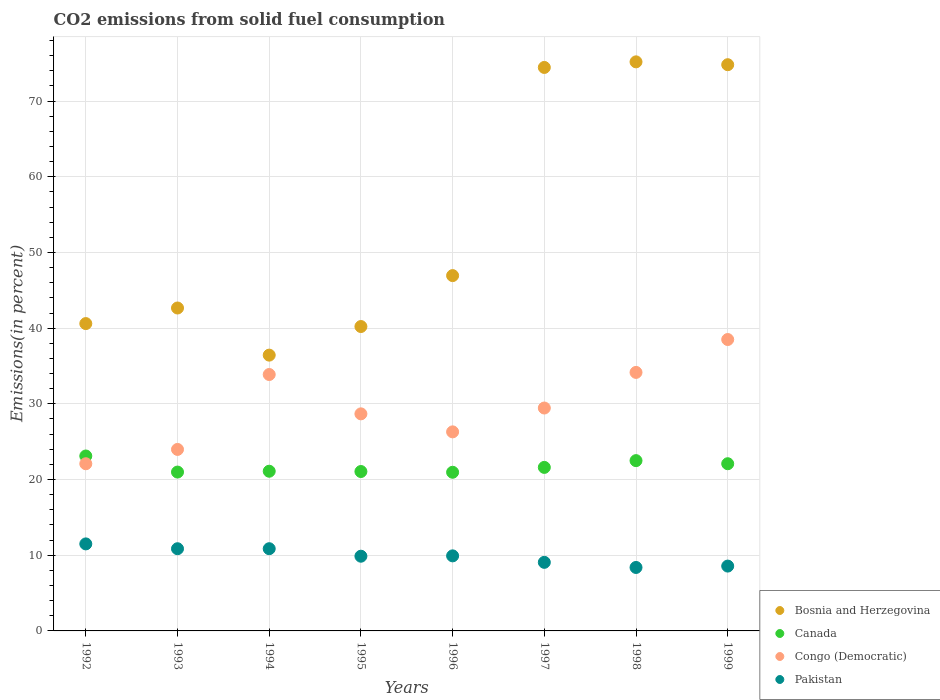How many different coloured dotlines are there?
Your response must be concise. 4. Is the number of dotlines equal to the number of legend labels?
Offer a terse response. Yes. What is the total CO2 emitted in Canada in 1999?
Your answer should be very brief. 22.09. Across all years, what is the maximum total CO2 emitted in Bosnia and Herzegovina?
Keep it short and to the point. 75.18. Across all years, what is the minimum total CO2 emitted in Pakistan?
Offer a terse response. 8.38. In which year was the total CO2 emitted in Canada minimum?
Make the answer very short. 1996. What is the total total CO2 emitted in Pakistan in the graph?
Provide a succinct answer. 79.01. What is the difference between the total CO2 emitted in Pakistan in 1995 and that in 1996?
Provide a succinct answer. -0.05. What is the difference between the total CO2 emitted in Bosnia and Herzegovina in 1992 and the total CO2 emitted in Pakistan in 1995?
Offer a terse response. 30.73. What is the average total CO2 emitted in Canada per year?
Ensure brevity in your answer.  21.68. In the year 1993, what is the difference between the total CO2 emitted in Congo (Democratic) and total CO2 emitted in Pakistan?
Keep it short and to the point. 13.12. What is the ratio of the total CO2 emitted in Bosnia and Herzegovina in 1992 to that in 1997?
Your answer should be compact. 0.55. What is the difference between the highest and the second highest total CO2 emitted in Pakistan?
Provide a succinct answer. 0.63. What is the difference between the highest and the lowest total CO2 emitted in Canada?
Your answer should be very brief. 2.15. In how many years, is the total CO2 emitted in Canada greater than the average total CO2 emitted in Canada taken over all years?
Provide a short and direct response. 3. Is the sum of the total CO2 emitted in Congo (Democratic) in 1994 and 1995 greater than the maximum total CO2 emitted in Pakistan across all years?
Keep it short and to the point. Yes. Does the total CO2 emitted in Bosnia and Herzegovina monotonically increase over the years?
Offer a very short reply. No. How many dotlines are there?
Provide a short and direct response. 4. How many years are there in the graph?
Keep it short and to the point. 8. What is the difference between two consecutive major ticks on the Y-axis?
Your response must be concise. 10. Are the values on the major ticks of Y-axis written in scientific E-notation?
Your response must be concise. No. Where does the legend appear in the graph?
Give a very brief answer. Bottom right. How are the legend labels stacked?
Your answer should be very brief. Vertical. What is the title of the graph?
Provide a succinct answer. CO2 emissions from solid fuel consumption. Does "Finland" appear as one of the legend labels in the graph?
Make the answer very short. No. What is the label or title of the X-axis?
Ensure brevity in your answer.  Years. What is the label or title of the Y-axis?
Offer a very short reply. Emissions(in percent). What is the Emissions(in percent) in Bosnia and Herzegovina in 1992?
Ensure brevity in your answer.  40.6. What is the Emissions(in percent) in Canada in 1992?
Your answer should be compact. 23.11. What is the Emissions(in percent) in Congo (Democratic) in 1992?
Your answer should be compact. 22.09. What is the Emissions(in percent) in Pakistan in 1992?
Your answer should be very brief. 11.5. What is the Emissions(in percent) of Bosnia and Herzegovina in 1993?
Keep it short and to the point. 42.66. What is the Emissions(in percent) of Canada in 1993?
Your response must be concise. 20.99. What is the Emissions(in percent) of Congo (Democratic) in 1993?
Offer a very short reply. 23.98. What is the Emissions(in percent) in Pakistan in 1993?
Offer a very short reply. 10.86. What is the Emissions(in percent) of Bosnia and Herzegovina in 1994?
Make the answer very short. 36.44. What is the Emissions(in percent) in Canada in 1994?
Ensure brevity in your answer.  21.1. What is the Emissions(in percent) in Congo (Democratic) in 1994?
Give a very brief answer. 33.88. What is the Emissions(in percent) of Pakistan in 1994?
Keep it short and to the point. 10.86. What is the Emissions(in percent) of Bosnia and Herzegovina in 1995?
Make the answer very short. 40.21. What is the Emissions(in percent) in Canada in 1995?
Offer a terse response. 21.06. What is the Emissions(in percent) in Congo (Democratic) in 1995?
Make the answer very short. 28.68. What is the Emissions(in percent) in Pakistan in 1995?
Provide a succinct answer. 9.87. What is the Emissions(in percent) of Bosnia and Herzegovina in 1996?
Your answer should be very brief. 46.94. What is the Emissions(in percent) in Canada in 1996?
Give a very brief answer. 20.96. What is the Emissions(in percent) of Congo (Democratic) in 1996?
Make the answer very short. 26.3. What is the Emissions(in percent) in Pakistan in 1996?
Your answer should be compact. 9.92. What is the Emissions(in percent) of Bosnia and Herzegovina in 1997?
Ensure brevity in your answer.  74.44. What is the Emissions(in percent) in Canada in 1997?
Your response must be concise. 21.6. What is the Emissions(in percent) in Congo (Democratic) in 1997?
Offer a very short reply. 29.45. What is the Emissions(in percent) in Pakistan in 1997?
Ensure brevity in your answer.  9.06. What is the Emissions(in percent) in Bosnia and Herzegovina in 1998?
Give a very brief answer. 75.18. What is the Emissions(in percent) of Canada in 1998?
Keep it short and to the point. 22.5. What is the Emissions(in percent) of Congo (Democratic) in 1998?
Your answer should be very brief. 34.15. What is the Emissions(in percent) of Pakistan in 1998?
Keep it short and to the point. 8.38. What is the Emissions(in percent) of Bosnia and Herzegovina in 1999?
Your answer should be very brief. 74.81. What is the Emissions(in percent) in Canada in 1999?
Your answer should be compact. 22.09. What is the Emissions(in percent) in Congo (Democratic) in 1999?
Make the answer very short. 38.5. What is the Emissions(in percent) of Pakistan in 1999?
Provide a succinct answer. 8.57. Across all years, what is the maximum Emissions(in percent) in Bosnia and Herzegovina?
Your answer should be very brief. 75.18. Across all years, what is the maximum Emissions(in percent) in Canada?
Offer a very short reply. 23.11. Across all years, what is the maximum Emissions(in percent) in Congo (Democratic)?
Provide a succinct answer. 38.5. Across all years, what is the maximum Emissions(in percent) of Pakistan?
Keep it short and to the point. 11.5. Across all years, what is the minimum Emissions(in percent) in Bosnia and Herzegovina?
Give a very brief answer. 36.44. Across all years, what is the minimum Emissions(in percent) in Canada?
Provide a short and direct response. 20.96. Across all years, what is the minimum Emissions(in percent) of Congo (Democratic)?
Make the answer very short. 22.09. Across all years, what is the minimum Emissions(in percent) in Pakistan?
Your answer should be very brief. 8.38. What is the total Emissions(in percent) in Bosnia and Herzegovina in the graph?
Keep it short and to the point. 431.29. What is the total Emissions(in percent) of Canada in the graph?
Make the answer very short. 173.4. What is the total Emissions(in percent) in Congo (Democratic) in the graph?
Make the answer very short. 237.02. What is the total Emissions(in percent) of Pakistan in the graph?
Give a very brief answer. 79.01. What is the difference between the Emissions(in percent) in Bosnia and Herzegovina in 1992 and that in 1993?
Your answer should be very brief. -2.06. What is the difference between the Emissions(in percent) of Canada in 1992 and that in 1993?
Keep it short and to the point. 2.12. What is the difference between the Emissions(in percent) in Congo (Democratic) in 1992 and that in 1993?
Make the answer very short. -1.89. What is the difference between the Emissions(in percent) of Pakistan in 1992 and that in 1993?
Make the answer very short. 0.64. What is the difference between the Emissions(in percent) of Bosnia and Herzegovina in 1992 and that in 1994?
Provide a succinct answer. 4.17. What is the difference between the Emissions(in percent) in Canada in 1992 and that in 1994?
Offer a very short reply. 2.01. What is the difference between the Emissions(in percent) in Congo (Democratic) in 1992 and that in 1994?
Ensure brevity in your answer.  -11.79. What is the difference between the Emissions(in percent) in Pakistan in 1992 and that in 1994?
Give a very brief answer. 0.63. What is the difference between the Emissions(in percent) in Bosnia and Herzegovina in 1992 and that in 1995?
Your answer should be very brief. 0.39. What is the difference between the Emissions(in percent) of Canada in 1992 and that in 1995?
Ensure brevity in your answer.  2.05. What is the difference between the Emissions(in percent) of Congo (Democratic) in 1992 and that in 1995?
Offer a terse response. -6.59. What is the difference between the Emissions(in percent) of Pakistan in 1992 and that in 1995?
Your answer should be compact. 1.63. What is the difference between the Emissions(in percent) of Bosnia and Herzegovina in 1992 and that in 1996?
Offer a very short reply. -6.34. What is the difference between the Emissions(in percent) of Canada in 1992 and that in 1996?
Make the answer very short. 2.15. What is the difference between the Emissions(in percent) of Congo (Democratic) in 1992 and that in 1996?
Keep it short and to the point. -4.21. What is the difference between the Emissions(in percent) in Pakistan in 1992 and that in 1996?
Offer a terse response. 1.58. What is the difference between the Emissions(in percent) of Bosnia and Herzegovina in 1992 and that in 1997?
Provide a succinct answer. -33.84. What is the difference between the Emissions(in percent) of Canada in 1992 and that in 1997?
Give a very brief answer. 1.51. What is the difference between the Emissions(in percent) of Congo (Democratic) in 1992 and that in 1997?
Provide a short and direct response. -7.36. What is the difference between the Emissions(in percent) of Pakistan in 1992 and that in 1997?
Ensure brevity in your answer.  2.44. What is the difference between the Emissions(in percent) of Bosnia and Herzegovina in 1992 and that in 1998?
Offer a very short reply. -34.58. What is the difference between the Emissions(in percent) of Canada in 1992 and that in 1998?
Ensure brevity in your answer.  0.61. What is the difference between the Emissions(in percent) of Congo (Democratic) in 1992 and that in 1998?
Keep it short and to the point. -12.07. What is the difference between the Emissions(in percent) in Pakistan in 1992 and that in 1998?
Ensure brevity in your answer.  3.11. What is the difference between the Emissions(in percent) of Bosnia and Herzegovina in 1992 and that in 1999?
Your response must be concise. -34.2. What is the difference between the Emissions(in percent) of Canada in 1992 and that in 1999?
Your response must be concise. 1.02. What is the difference between the Emissions(in percent) in Congo (Democratic) in 1992 and that in 1999?
Your answer should be compact. -16.41. What is the difference between the Emissions(in percent) in Pakistan in 1992 and that in 1999?
Provide a short and direct response. 2.93. What is the difference between the Emissions(in percent) in Bosnia and Herzegovina in 1993 and that in 1994?
Your answer should be very brief. 6.23. What is the difference between the Emissions(in percent) in Canada in 1993 and that in 1994?
Your response must be concise. -0.11. What is the difference between the Emissions(in percent) of Congo (Democratic) in 1993 and that in 1994?
Make the answer very short. -9.9. What is the difference between the Emissions(in percent) of Pakistan in 1993 and that in 1994?
Offer a very short reply. -0. What is the difference between the Emissions(in percent) of Bosnia and Herzegovina in 1993 and that in 1995?
Offer a very short reply. 2.45. What is the difference between the Emissions(in percent) in Canada in 1993 and that in 1995?
Keep it short and to the point. -0.07. What is the difference between the Emissions(in percent) of Congo (Democratic) in 1993 and that in 1995?
Provide a short and direct response. -4.7. What is the difference between the Emissions(in percent) in Bosnia and Herzegovina in 1993 and that in 1996?
Your answer should be very brief. -4.28. What is the difference between the Emissions(in percent) in Canada in 1993 and that in 1996?
Provide a short and direct response. 0.03. What is the difference between the Emissions(in percent) in Congo (Democratic) in 1993 and that in 1996?
Make the answer very short. -2.32. What is the difference between the Emissions(in percent) in Pakistan in 1993 and that in 1996?
Provide a short and direct response. 0.94. What is the difference between the Emissions(in percent) in Bosnia and Herzegovina in 1993 and that in 1997?
Keep it short and to the point. -31.78. What is the difference between the Emissions(in percent) of Canada in 1993 and that in 1997?
Your answer should be very brief. -0.62. What is the difference between the Emissions(in percent) in Congo (Democratic) in 1993 and that in 1997?
Your response must be concise. -5.47. What is the difference between the Emissions(in percent) of Pakistan in 1993 and that in 1997?
Keep it short and to the point. 1.8. What is the difference between the Emissions(in percent) in Bosnia and Herzegovina in 1993 and that in 1998?
Offer a terse response. -32.52. What is the difference between the Emissions(in percent) in Canada in 1993 and that in 1998?
Your response must be concise. -1.51. What is the difference between the Emissions(in percent) of Congo (Democratic) in 1993 and that in 1998?
Ensure brevity in your answer.  -10.17. What is the difference between the Emissions(in percent) of Pakistan in 1993 and that in 1998?
Your response must be concise. 2.47. What is the difference between the Emissions(in percent) of Bosnia and Herzegovina in 1993 and that in 1999?
Your response must be concise. -32.14. What is the difference between the Emissions(in percent) of Canada in 1993 and that in 1999?
Offer a terse response. -1.1. What is the difference between the Emissions(in percent) of Congo (Democratic) in 1993 and that in 1999?
Provide a succinct answer. -14.52. What is the difference between the Emissions(in percent) of Pakistan in 1993 and that in 1999?
Provide a succinct answer. 2.29. What is the difference between the Emissions(in percent) of Bosnia and Herzegovina in 1994 and that in 1995?
Your response must be concise. -3.78. What is the difference between the Emissions(in percent) in Canada in 1994 and that in 1995?
Give a very brief answer. 0.04. What is the difference between the Emissions(in percent) of Congo (Democratic) in 1994 and that in 1995?
Give a very brief answer. 5.2. What is the difference between the Emissions(in percent) of Bosnia and Herzegovina in 1994 and that in 1996?
Keep it short and to the point. -10.51. What is the difference between the Emissions(in percent) in Canada in 1994 and that in 1996?
Keep it short and to the point. 0.14. What is the difference between the Emissions(in percent) in Congo (Democratic) in 1994 and that in 1996?
Provide a short and direct response. 7.58. What is the difference between the Emissions(in percent) in Pakistan in 1994 and that in 1996?
Offer a very short reply. 0.95. What is the difference between the Emissions(in percent) of Bosnia and Herzegovina in 1994 and that in 1997?
Your answer should be very brief. -38.01. What is the difference between the Emissions(in percent) of Canada in 1994 and that in 1997?
Provide a short and direct response. -0.51. What is the difference between the Emissions(in percent) of Congo (Democratic) in 1994 and that in 1997?
Your answer should be very brief. 4.43. What is the difference between the Emissions(in percent) in Pakistan in 1994 and that in 1997?
Ensure brevity in your answer.  1.8. What is the difference between the Emissions(in percent) in Bosnia and Herzegovina in 1994 and that in 1998?
Give a very brief answer. -38.75. What is the difference between the Emissions(in percent) of Canada in 1994 and that in 1998?
Give a very brief answer. -1.4. What is the difference between the Emissions(in percent) of Congo (Democratic) in 1994 and that in 1998?
Keep it short and to the point. -0.28. What is the difference between the Emissions(in percent) of Pakistan in 1994 and that in 1998?
Your answer should be compact. 2.48. What is the difference between the Emissions(in percent) of Bosnia and Herzegovina in 1994 and that in 1999?
Ensure brevity in your answer.  -38.37. What is the difference between the Emissions(in percent) of Canada in 1994 and that in 1999?
Offer a very short reply. -0.99. What is the difference between the Emissions(in percent) in Congo (Democratic) in 1994 and that in 1999?
Offer a terse response. -4.62. What is the difference between the Emissions(in percent) of Pakistan in 1994 and that in 1999?
Make the answer very short. 2.3. What is the difference between the Emissions(in percent) of Bosnia and Herzegovina in 1995 and that in 1996?
Ensure brevity in your answer.  -6.73. What is the difference between the Emissions(in percent) in Canada in 1995 and that in 1996?
Give a very brief answer. 0.1. What is the difference between the Emissions(in percent) in Congo (Democratic) in 1995 and that in 1996?
Your answer should be compact. 2.38. What is the difference between the Emissions(in percent) in Pakistan in 1995 and that in 1996?
Provide a succinct answer. -0.05. What is the difference between the Emissions(in percent) in Bosnia and Herzegovina in 1995 and that in 1997?
Your response must be concise. -34.23. What is the difference between the Emissions(in percent) in Canada in 1995 and that in 1997?
Provide a short and direct response. -0.55. What is the difference between the Emissions(in percent) of Congo (Democratic) in 1995 and that in 1997?
Offer a very short reply. -0.77. What is the difference between the Emissions(in percent) in Pakistan in 1995 and that in 1997?
Offer a very short reply. 0.81. What is the difference between the Emissions(in percent) in Bosnia and Herzegovina in 1995 and that in 1998?
Offer a very short reply. -34.97. What is the difference between the Emissions(in percent) in Canada in 1995 and that in 1998?
Provide a succinct answer. -1.44. What is the difference between the Emissions(in percent) of Congo (Democratic) in 1995 and that in 1998?
Your answer should be very brief. -5.48. What is the difference between the Emissions(in percent) in Pakistan in 1995 and that in 1998?
Make the answer very short. 1.49. What is the difference between the Emissions(in percent) in Bosnia and Herzegovina in 1995 and that in 1999?
Keep it short and to the point. -34.59. What is the difference between the Emissions(in percent) in Canada in 1995 and that in 1999?
Ensure brevity in your answer.  -1.03. What is the difference between the Emissions(in percent) of Congo (Democratic) in 1995 and that in 1999?
Your answer should be very brief. -9.82. What is the difference between the Emissions(in percent) in Pakistan in 1995 and that in 1999?
Your response must be concise. 1.3. What is the difference between the Emissions(in percent) in Bosnia and Herzegovina in 1996 and that in 1997?
Ensure brevity in your answer.  -27.5. What is the difference between the Emissions(in percent) of Canada in 1996 and that in 1997?
Keep it short and to the point. -0.64. What is the difference between the Emissions(in percent) in Congo (Democratic) in 1996 and that in 1997?
Provide a succinct answer. -3.15. What is the difference between the Emissions(in percent) of Pakistan in 1996 and that in 1997?
Provide a short and direct response. 0.86. What is the difference between the Emissions(in percent) in Bosnia and Herzegovina in 1996 and that in 1998?
Your response must be concise. -28.24. What is the difference between the Emissions(in percent) in Canada in 1996 and that in 1998?
Give a very brief answer. -1.54. What is the difference between the Emissions(in percent) of Congo (Democratic) in 1996 and that in 1998?
Make the answer very short. -7.86. What is the difference between the Emissions(in percent) in Pakistan in 1996 and that in 1998?
Your response must be concise. 1.53. What is the difference between the Emissions(in percent) of Bosnia and Herzegovina in 1996 and that in 1999?
Make the answer very short. -27.86. What is the difference between the Emissions(in percent) in Canada in 1996 and that in 1999?
Give a very brief answer. -1.13. What is the difference between the Emissions(in percent) in Congo (Democratic) in 1996 and that in 1999?
Make the answer very short. -12.2. What is the difference between the Emissions(in percent) of Pakistan in 1996 and that in 1999?
Your answer should be very brief. 1.35. What is the difference between the Emissions(in percent) of Bosnia and Herzegovina in 1997 and that in 1998?
Keep it short and to the point. -0.74. What is the difference between the Emissions(in percent) of Canada in 1997 and that in 1998?
Provide a succinct answer. -0.89. What is the difference between the Emissions(in percent) in Congo (Democratic) in 1997 and that in 1998?
Your answer should be compact. -4.7. What is the difference between the Emissions(in percent) in Pakistan in 1997 and that in 1998?
Make the answer very short. 0.68. What is the difference between the Emissions(in percent) of Bosnia and Herzegovina in 1997 and that in 1999?
Your answer should be compact. -0.36. What is the difference between the Emissions(in percent) of Canada in 1997 and that in 1999?
Offer a terse response. -0.49. What is the difference between the Emissions(in percent) of Congo (Democratic) in 1997 and that in 1999?
Give a very brief answer. -9.05. What is the difference between the Emissions(in percent) of Pakistan in 1997 and that in 1999?
Ensure brevity in your answer.  0.49. What is the difference between the Emissions(in percent) of Bosnia and Herzegovina in 1998 and that in 1999?
Provide a short and direct response. 0.38. What is the difference between the Emissions(in percent) in Canada in 1998 and that in 1999?
Your answer should be very brief. 0.41. What is the difference between the Emissions(in percent) of Congo (Democratic) in 1998 and that in 1999?
Your response must be concise. -4.35. What is the difference between the Emissions(in percent) of Pakistan in 1998 and that in 1999?
Offer a terse response. -0.18. What is the difference between the Emissions(in percent) of Bosnia and Herzegovina in 1992 and the Emissions(in percent) of Canada in 1993?
Keep it short and to the point. 19.62. What is the difference between the Emissions(in percent) in Bosnia and Herzegovina in 1992 and the Emissions(in percent) in Congo (Democratic) in 1993?
Offer a very short reply. 16.62. What is the difference between the Emissions(in percent) of Bosnia and Herzegovina in 1992 and the Emissions(in percent) of Pakistan in 1993?
Your response must be concise. 29.74. What is the difference between the Emissions(in percent) in Canada in 1992 and the Emissions(in percent) in Congo (Democratic) in 1993?
Keep it short and to the point. -0.87. What is the difference between the Emissions(in percent) in Canada in 1992 and the Emissions(in percent) in Pakistan in 1993?
Your answer should be very brief. 12.25. What is the difference between the Emissions(in percent) of Congo (Democratic) in 1992 and the Emissions(in percent) of Pakistan in 1993?
Your answer should be very brief. 11.23. What is the difference between the Emissions(in percent) in Bosnia and Herzegovina in 1992 and the Emissions(in percent) in Canada in 1994?
Your answer should be compact. 19.51. What is the difference between the Emissions(in percent) of Bosnia and Herzegovina in 1992 and the Emissions(in percent) of Congo (Democratic) in 1994?
Provide a short and direct response. 6.73. What is the difference between the Emissions(in percent) in Bosnia and Herzegovina in 1992 and the Emissions(in percent) in Pakistan in 1994?
Offer a terse response. 29.74. What is the difference between the Emissions(in percent) in Canada in 1992 and the Emissions(in percent) in Congo (Democratic) in 1994?
Your response must be concise. -10.77. What is the difference between the Emissions(in percent) in Canada in 1992 and the Emissions(in percent) in Pakistan in 1994?
Give a very brief answer. 12.25. What is the difference between the Emissions(in percent) in Congo (Democratic) in 1992 and the Emissions(in percent) in Pakistan in 1994?
Make the answer very short. 11.23. What is the difference between the Emissions(in percent) of Bosnia and Herzegovina in 1992 and the Emissions(in percent) of Canada in 1995?
Keep it short and to the point. 19.54. What is the difference between the Emissions(in percent) in Bosnia and Herzegovina in 1992 and the Emissions(in percent) in Congo (Democratic) in 1995?
Provide a succinct answer. 11.93. What is the difference between the Emissions(in percent) in Bosnia and Herzegovina in 1992 and the Emissions(in percent) in Pakistan in 1995?
Your response must be concise. 30.73. What is the difference between the Emissions(in percent) of Canada in 1992 and the Emissions(in percent) of Congo (Democratic) in 1995?
Offer a very short reply. -5.57. What is the difference between the Emissions(in percent) in Canada in 1992 and the Emissions(in percent) in Pakistan in 1995?
Make the answer very short. 13.24. What is the difference between the Emissions(in percent) of Congo (Democratic) in 1992 and the Emissions(in percent) of Pakistan in 1995?
Offer a terse response. 12.22. What is the difference between the Emissions(in percent) of Bosnia and Herzegovina in 1992 and the Emissions(in percent) of Canada in 1996?
Keep it short and to the point. 19.64. What is the difference between the Emissions(in percent) in Bosnia and Herzegovina in 1992 and the Emissions(in percent) in Congo (Democratic) in 1996?
Make the answer very short. 14.3. What is the difference between the Emissions(in percent) in Bosnia and Herzegovina in 1992 and the Emissions(in percent) in Pakistan in 1996?
Keep it short and to the point. 30.69. What is the difference between the Emissions(in percent) in Canada in 1992 and the Emissions(in percent) in Congo (Democratic) in 1996?
Make the answer very short. -3.19. What is the difference between the Emissions(in percent) of Canada in 1992 and the Emissions(in percent) of Pakistan in 1996?
Give a very brief answer. 13.19. What is the difference between the Emissions(in percent) of Congo (Democratic) in 1992 and the Emissions(in percent) of Pakistan in 1996?
Make the answer very short. 12.17. What is the difference between the Emissions(in percent) of Bosnia and Herzegovina in 1992 and the Emissions(in percent) of Canada in 1997?
Provide a short and direct response. 19. What is the difference between the Emissions(in percent) of Bosnia and Herzegovina in 1992 and the Emissions(in percent) of Congo (Democratic) in 1997?
Your response must be concise. 11.15. What is the difference between the Emissions(in percent) in Bosnia and Herzegovina in 1992 and the Emissions(in percent) in Pakistan in 1997?
Offer a terse response. 31.54. What is the difference between the Emissions(in percent) of Canada in 1992 and the Emissions(in percent) of Congo (Democratic) in 1997?
Your answer should be very brief. -6.34. What is the difference between the Emissions(in percent) of Canada in 1992 and the Emissions(in percent) of Pakistan in 1997?
Ensure brevity in your answer.  14.05. What is the difference between the Emissions(in percent) of Congo (Democratic) in 1992 and the Emissions(in percent) of Pakistan in 1997?
Make the answer very short. 13.03. What is the difference between the Emissions(in percent) of Bosnia and Herzegovina in 1992 and the Emissions(in percent) of Canada in 1998?
Offer a terse response. 18.11. What is the difference between the Emissions(in percent) of Bosnia and Herzegovina in 1992 and the Emissions(in percent) of Congo (Democratic) in 1998?
Offer a very short reply. 6.45. What is the difference between the Emissions(in percent) in Bosnia and Herzegovina in 1992 and the Emissions(in percent) in Pakistan in 1998?
Offer a terse response. 32.22. What is the difference between the Emissions(in percent) of Canada in 1992 and the Emissions(in percent) of Congo (Democratic) in 1998?
Your answer should be compact. -11.04. What is the difference between the Emissions(in percent) of Canada in 1992 and the Emissions(in percent) of Pakistan in 1998?
Your answer should be very brief. 14.73. What is the difference between the Emissions(in percent) of Congo (Democratic) in 1992 and the Emissions(in percent) of Pakistan in 1998?
Offer a terse response. 13.7. What is the difference between the Emissions(in percent) in Bosnia and Herzegovina in 1992 and the Emissions(in percent) in Canada in 1999?
Give a very brief answer. 18.51. What is the difference between the Emissions(in percent) of Bosnia and Herzegovina in 1992 and the Emissions(in percent) of Congo (Democratic) in 1999?
Provide a succinct answer. 2.1. What is the difference between the Emissions(in percent) of Bosnia and Herzegovina in 1992 and the Emissions(in percent) of Pakistan in 1999?
Give a very brief answer. 32.04. What is the difference between the Emissions(in percent) of Canada in 1992 and the Emissions(in percent) of Congo (Democratic) in 1999?
Your response must be concise. -15.39. What is the difference between the Emissions(in percent) of Canada in 1992 and the Emissions(in percent) of Pakistan in 1999?
Your response must be concise. 14.54. What is the difference between the Emissions(in percent) in Congo (Democratic) in 1992 and the Emissions(in percent) in Pakistan in 1999?
Give a very brief answer. 13.52. What is the difference between the Emissions(in percent) of Bosnia and Herzegovina in 1993 and the Emissions(in percent) of Canada in 1994?
Ensure brevity in your answer.  21.56. What is the difference between the Emissions(in percent) of Bosnia and Herzegovina in 1993 and the Emissions(in percent) of Congo (Democratic) in 1994?
Ensure brevity in your answer.  8.79. What is the difference between the Emissions(in percent) of Bosnia and Herzegovina in 1993 and the Emissions(in percent) of Pakistan in 1994?
Provide a succinct answer. 31.8. What is the difference between the Emissions(in percent) of Canada in 1993 and the Emissions(in percent) of Congo (Democratic) in 1994?
Ensure brevity in your answer.  -12.89. What is the difference between the Emissions(in percent) of Canada in 1993 and the Emissions(in percent) of Pakistan in 1994?
Provide a short and direct response. 10.12. What is the difference between the Emissions(in percent) of Congo (Democratic) in 1993 and the Emissions(in percent) of Pakistan in 1994?
Your response must be concise. 13.12. What is the difference between the Emissions(in percent) of Bosnia and Herzegovina in 1993 and the Emissions(in percent) of Canada in 1995?
Keep it short and to the point. 21.6. What is the difference between the Emissions(in percent) in Bosnia and Herzegovina in 1993 and the Emissions(in percent) in Congo (Democratic) in 1995?
Provide a short and direct response. 13.98. What is the difference between the Emissions(in percent) of Bosnia and Herzegovina in 1993 and the Emissions(in percent) of Pakistan in 1995?
Make the answer very short. 32.79. What is the difference between the Emissions(in percent) of Canada in 1993 and the Emissions(in percent) of Congo (Democratic) in 1995?
Offer a terse response. -7.69. What is the difference between the Emissions(in percent) of Canada in 1993 and the Emissions(in percent) of Pakistan in 1995?
Ensure brevity in your answer.  11.12. What is the difference between the Emissions(in percent) of Congo (Democratic) in 1993 and the Emissions(in percent) of Pakistan in 1995?
Ensure brevity in your answer.  14.11. What is the difference between the Emissions(in percent) of Bosnia and Herzegovina in 1993 and the Emissions(in percent) of Canada in 1996?
Offer a terse response. 21.7. What is the difference between the Emissions(in percent) in Bosnia and Herzegovina in 1993 and the Emissions(in percent) in Congo (Democratic) in 1996?
Give a very brief answer. 16.36. What is the difference between the Emissions(in percent) in Bosnia and Herzegovina in 1993 and the Emissions(in percent) in Pakistan in 1996?
Ensure brevity in your answer.  32.75. What is the difference between the Emissions(in percent) of Canada in 1993 and the Emissions(in percent) of Congo (Democratic) in 1996?
Make the answer very short. -5.31. What is the difference between the Emissions(in percent) of Canada in 1993 and the Emissions(in percent) of Pakistan in 1996?
Offer a very short reply. 11.07. What is the difference between the Emissions(in percent) in Congo (Democratic) in 1993 and the Emissions(in percent) in Pakistan in 1996?
Provide a succinct answer. 14.06. What is the difference between the Emissions(in percent) of Bosnia and Herzegovina in 1993 and the Emissions(in percent) of Canada in 1997?
Your answer should be very brief. 21.06. What is the difference between the Emissions(in percent) of Bosnia and Herzegovina in 1993 and the Emissions(in percent) of Congo (Democratic) in 1997?
Ensure brevity in your answer.  13.21. What is the difference between the Emissions(in percent) in Bosnia and Herzegovina in 1993 and the Emissions(in percent) in Pakistan in 1997?
Give a very brief answer. 33.6. What is the difference between the Emissions(in percent) of Canada in 1993 and the Emissions(in percent) of Congo (Democratic) in 1997?
Provide a short and direct response. -8.46. What is the difference between the Emissions(in percent) of Canada in 1993 and the Emissions(in percent) of Pakistan in 1997?
Provide a succinct answer. 11.93. What is the difference between the Emissions(in percent) of Congo (Democratic) in 1993 and the Emissions(in percent) of Pakistan in 1997?
Offer a very short reply. 14.92. What is the difference between the Emissions(in percent) of Bosnia and Herzegovina in 1993 and the Emissions(in percent) of Canada in 1998?
Provide a short and direct response. 20.16. What is the difference between the Emissions(in percent) of Bosnia and Herzegovina in 1993 and the Emissions(in percent) of Congo (Democratic) in 1998?
Offer a very short reply. 8.51. What is the difference between the Emissions(in percent) in Bosnia and Herzegovina in 1993 and the Emissions(in percent) in Pakistan in 1998?
Offer a terse response. 34.28. What is the difference between the Emissions(in percent) of Canada in 1993 and the Emissions(in percent) of Congo (Democratic) in 1998?
Offer a terse response. -13.17. What is the difference between the Emissions(in percent) of Canada in 1993 and the Emissions(in percent) of Pakistan in 1998?
Give a very brief answer. 12.6. What is the difference between the Emissions(in percent) in Congo (Democratic) in 1993 and the Emissions(in percent) in Pakistan in 1998?
Your answer should be compact. 15.59. What is the difference between the Emissions(in percent) of Bosnia and Herzegovina in 1993 and the Emissions(in percent) of Canada in 1999?
Offer a very short reply. 20.57. What is the difference between the Emissions(in percent) of Bosnia and Herzegovina in 1993 and the Emissions(in percent) of Congo (Democratic) in 1999?
Make the answer very short. 4.16. What is the difference between the Emissions(in percent) in Bosnia and Herzegovina in 1993 and the Emissions(in percent) in Pakistan in 1999?
Keep it short and to the point. 34.1. What is the difference between the Emissions(in percent) in Canada in 1993 and the Emissions(in percent) in Congo (Democratic) in 1999?
Make the answer very short. -17.51. What is the difference between the Emissions(in percent) of Canada in 1993 and the Emissions(in percent) of Pakistan in 1999?
Your answer should be compact. 12.42. What is the difference between the Emissions(in percent) of Congo (Democratic) in 1993 and the Emissions(in percent) of Pakistan in 1999?
Offer a very short reply. 15.41. What is the difference between the Emissions(in percent) of Bosnia and Herzegovina in 1994 and the Emissions(in percent) of Canada in 1995?
Provide a succinct answer. 15.38. What is the difference between the Emissions(in percent) in Bosnia and Herzegovina in 1994 and the Emissions(in percent) in Congo (Democratic) in 1995?
Keep it short and to the point. 7.76. What is the difference between the Emissions(in percent) in Bosnia and Herzegovina in 1994 and the Emissions(in percent) in Pakistan in 1995?
Provide a short and direct response. 26.57. What is the difference between the Emissions(in percent) of Canada in 1994 and the Emissions(in percent) of Congo (Democratic) in 1995?
Make the answer very short. -7.58. What is the difference between the Emissions(in percent) in Canada in 1994 and the Emissions(in percent) in Pakistan in 1995?
Keep it short and to the point. 11.23. What is the difference between the Emissions(in percent) in Congo (Democratic) in 1994 and the Emissions(in percent) in Pakistan in 1995?
Give a very brief answer. 24.01. What is the difference between the Emissions(in percent) in Bosnia and Herzegovina in 1994 and the Emissions(in percent) in Canada in 1996?
Ensure brevity in your answer.  15.48. What is the difference between the Emissions(in percent) of Bosnia and Herzegovina in 1994 and the Emissions(in percent) of Congo (Democratic) in 1996?
Provide a succinct answer. 10.14. What is the difference between the Emissions(in percent) of Bosnia and Herzegovina in 1994 and the Emissions(in percent) of Pakistan in 1996?
Provide a succinct answer. 26.52. What is the difference between the Emissions(in percent) in Canada in 1994 and the Emissions(in percent) in Congo (Democratic) in 1996?
Give a very brief answer. -5.2. What is the difference between the Emissions(in percent) of Canada in 1994 and the Emissions(in percent) of Pakistan in 1996?
Keep it short and to the point. 11.18. What is the difference between the Emissions(in percent) of Congo (Democratic) in 1994 and the Emissions(in percent) of Pakistan in 1996?
Your answer should be compact. 23.96. What is the difference between the Emissions(in percent) of Bosnia and Herzegovina in 1994 and the Emissions(in percent) of Canada in 1997?
Your response must be concise. 14.83. What is the difference between the Emissions(in percent) of Bosnia and Herzegovina in 1994 and the Emissions(in percent) of Congo (Democratic) in 1997?
Ensure brevity in your answer.  6.99. What is the difference between the Emissions(in percent) in Bosnia and Herzegovina in 1994 and the Emissions(in percent) in Pakistan in 1997?
Your answer should be compact. 27.38. What is the difference between the Emissions(in percent) of Canada in 1994 and the Emissions(in percent) of Congo (Democratic) in 1997?
Your response must be concise. -8.35. What is the difference between the Emissions(in percent) in Canada in 1994 and the Emissions(in percent) in Pakistan in 1997?
Your answer should be very brief. 12.04. What is the difference between the Emissions(in percent) of Congo (Democratic) in 1994 and the Emissions(in percent) of Pakistan in 1997?
Ensure brevity in your answer.  24.82. What is the difference between the Emissions(in percent) of Bosnia and Herzegovina in 1994 and the Emissions(in percent) of Canada in 1998?
Your answer should be compact. 13.94. What is the difference between the Emissions(in percent) in Bosnia and Herzegovina in 1994 and the Emissions(in percent) in Congo (Democratic) in 1998?
Provide a succinct answer. 2.28. What is the difference between the Emissions(in percent) in Bosnia and Herzegovina in 1994 and the Emissions(in percent) in Pakistan in 1998?
Make the answer very short. 28.05. What is the difference between the Emissions(in percent) of Canada in 1994 and the Emissions(in percent) of Congo (Democratic) in 1998?
Keep it short and to the point. -13.06. What is the difference between the Emissions(in percent) of Canada in 1994 and the Emissions(in percent) of Pakistan in 1998?
Your answer should be compact. 12.71. What is the difference between the Emissions(in percent) in Congo (Democratic) in 1994 and the Emissions(in percent) in Pakistan in 1998?
Give a very brief answer. 25.49. What is the difference between the Emissions(in percent) in Bosnia and Herzegovina in 1994 and the Emissions(in percent) in Canada in 1999?
Your answer should be very brief. 14.35. What is the difference between the Emissions(in percent) of Bosnia and Herzegovina in 1994 and the Emissions(in percent) of Congo (Democratic) in 1999?
Provide a succinct answer. -2.06. What is the difference between the Emissions(in percent) in Bosnia and Herzegovina in 1994 and the Emissions(in percent) in Pakistan in 1999?
Provide a succinct answer. 27.87. What is the difference between the Emissions(in percent) in Canada in 1994 and the Emissions(in percent) in Congo (Democratic) in 1999?
Your answer should be very brief. -17.4. What is the difference between the Emissions(in percent) of Canada in 1994 and the Emissions(in percent) of Pakistan in 1999?
Your response must be concise. 12.53. What is the difference between the Emissions(in percent) of Congo (Democratic) in 1994 and the Emissions(in percent) of Pakistan in 1999?
Provide a succinct answer. 25.31. What is the difference between the Emissions(in percent) of Bosnia and Herzegovina in 1995 and the Emissions(in percent) of Canada in 1996?
Ensure brevity in your answer.  19.25. What is the difference between the Emissions(in percent) of Bosnia and Herzegovina in 1995 and the Emissions(in percent) of Congo (Democratic) in 1996?
Give a very brief answer. 13.92. What is the difference between the Emissions(in percent) of Bosnia and Herzegovina in 1995 and the Emissions(in percent) of Pakistan in 1996?
Keep it short and to the point. 30.3. What is the difference between the Emissions(in percent) in Canada in 1995 and the Emissions(in percent) in Congo (Democratic) in 1996?
Provide a short and direct response. -5.24. What is the difference between the Emissions(in percent) in Canada in 1995 and the Emissions(in percent) in Pakistan in 1996?
Keep it short and to the point. 11.14. What is the difference between the Emissions(in percent) in Congo (Democratic) in 1995 and the Emissions(in percent) in Pakistan in 1996?
Offer a very short reply. 18.76. What is the difference between the Emissions(in percent) of Bosnia and Herzegovina in 1995 and the Emissions(in percent) of Canada in 1997?
Provide a short and direct response. 18.61. What is the difference between the Emissions(in percent) of Bosnia and Herzegovina in 1995 and the Emissions(in percent) of Congo (Democratic) in 1997?
Keep it short and to the point. 10.77. What is the difference between the Emissions(in percent) of Bosnia and Herzegovina in 1995 and the Emissions(in percent) of Pakistan in 1997?
Provide a succinct answer. 31.15. What is the difference between the Emissions(in percent) in Canada in 1995 and the Emissions(in percent) in Congo (Democratic) in 1997?
Give a very brief answer. -8.39. What is the difference between the Emissions(in percent) in Canada in 1995 and the Emissions(in percent) in Pakistan in 1997?
Provide a short and direct response. 12. What is the difference between the Emissions(in percent) of Congo (Democratic) in 1995 and the Emissions(in percent) of Pakistan in 1997?
Keep it short and to the point. 19.62. What is the difference between the Emissions(in percent) of Bosnia and Herzegovina in 1995 and the Emissions(in percent) of Canada in 1998?
Give a very brief answer. 17.72. What is the difference between the Emissions(in percent) in Bosnia and Herzegovina in 1995 and the Emissions(in percent) in Congo (Democratic) in 1998?
Give a very brief answer. 6.06. What is the difference between the Emissions(in percent) of Bosnia and Herzegovina in 1995 and the Emissions(in percent) of Pakistan in 1998?
Make the answer very short. 31.83. What is the difference between the Emissions(in percent) in Canada in 1995 and the Emissions(in percent) in Congo (Democratic) in 1998?
Offer a terse response. -13.09. What is the difference between the Emissions(in percent) in Canada in 1995 and the Emissions(in percent) in Pakistan in 1998?
Give a very brief answer. 12.67. What is the difference between the Emissions(in percent) in Congo (Democratic) in 1995 and the Emissions(in percent) in Pakistan in 1998?
Provide a succinct answer. 20.29. What is the difference between the Emissions(in percent) of Bosnia and Herzegovina in 1995 and the Emissions(in percent) of Canada in 1999?
Your answer should be very brief. 18.12. What is the difference between the Emissions(in percent) in Bosnia and Herzegovina in 1995 and the Emissions(in percent) in Congo (Democratic) in 1999?
Keep it short and to the point. 1.71. What is the difference between the Emissions(in percent) of Bosnia and Herzegovina in 1995 and the Emissions(in percent) of Pakistan in 1999?
Your answer should be compact. 31.65. What is the difference between the Emissions(in percent) in Canada in 1995 and the Emissions(in percent) in Congo (Democratic) in 1999?
Keep it short and to the point. -17.44. What is the difference between the Emissions(in percent) of Canada in 1995 and the Emissions(in percent) of Pakistan in 1999?
Provide a short and direct response. 12.49. What is the difference between the Emissions(in percent) in Congo (Democratic) in 1995 and the Emissions(in percent) in Pakistan in 1999?
Provide a succinct answer. 20.11. What is the difference between the Emissions(in percent) of Bosnia and Herzegovina in 1996 and the Emissions(in percent) of Canada in 1997?
Your response must be concise. 25.34. What is the difference between the Emissions(in percent) of Bosnia and Herzegovina in 1996 and the Emissions(in percent) of Congo (Democratic) in 1997?
Your answer should be compact. 17.49. What is the difference between the Emissions(in percent) of Bosnia and Herzegovina in 1996 and the Emissions(in percent) of Pakistan in 1997?
Keep it short and to the point. 37.88. What is the difference between the Emissions(in percent) in Canada in 1996 and the Emissions(in percent) in Congo (Democratic) in 1997?
Your answer should be very brief. -8.49. What is the difference between the Emissions(in percent) in Canada in 1996 and the Emissions(in percent) in Pakistan in 1997?
Offer a very short reply. 11.9. What is the difference between the Emissions(in percent) in Congo (Democratic) in 1996 and the Emissions(in percent) in Pakistan in 1997?
Provide a succinct answer. 17.24. What is the difference between the Emissions(in percent) of Bosnia and Herzegovina in 1996 and the Emissions(in percent) of Canada in 1998?
Keep it short and to the point. 24.45. What is the difference between the Emissions(in percent) of Bosnia and Herzegovina in 1996 and the Emissions(in percent) of Congo (Democratic) in 1998?
Ensure brevity in your answer.  12.79. What is the difference between the Emissions(in percent) in Bosnia and Herzegovina in 1996 and the Emissions(in percent) in Pakistan in 1998?
Your response must be concise. 38.56. What is the difference between the Emissions(in percent) of Canada in 1996 and the Emissions(in percent) of Congo (Democratic) in 1998?
Offer a terse response. -13.19. What is the difference between the Emissions(in percent) of Canada in 1996 and the Emissions(in percent) of Pakistan in 1998?
Provide a short and direct response. 12.58. What is the difference between the Emissions(in percent) of Congo (Democratic) in 1996 and the Emissions(in percent) of Pakistan in 1998?
Make the answer very short. 17.91. What is the difference between the Emissions(in percent) in Bosnia and Herzegovina in 1996 and the Emissions(in percent) in Canada in 1999?
Make the answer very short. 24.85. What is the difference between the Emissions(in percent) of Bosnia and Herzegovina in 1996 and the Emissions(in percent) of Congo (Democratic) in 1999?
Give a very brief answer. 8.44. What is the difference between the Emissions(in percent) of Bosnia and Herzegovina in 1996 and the Emissions(in percent) of Pakistan in 1999?
Offer a very short reply. 38.38. What is the difference between the Emissions(in percent) in Canada in 1996 and the Emissions(in percent) in Congo (Democratic) in 1999?
Give a very brief answer. -17.54. What is the difference between the Emissions(in percent) in Canada in 1996 and the Emissions(in percent) in Pakistan in 1999?
Offer a very short reply. 12.39. What is the difference between the Emissions(in percent) in Congo (Democratic) in 1996 and the Emissions(in percent) in Pakistan in 1999?
Offer a very short reply. 17.73. What is the difference between the Emissions(in percent) of Bosnia and Herzegovina in 1997 and the Emissions(in percent) of Canada in 1998?
Your response must be concise. 51.95. What is the difference between the Emissions(in percent) in Bosnia and Herzegovina in 1997 and the Emissions(in percent) in Congo (Democratic) in 1998?
Ensure brevity in your answer.  40.29. What is the difference between the Emissions(in percent) in Bosnia and Herzegovina in 1997 and the Emissions(in percent) in Pakistan in 1998?
Your answer should be very brief. 66.06. What is the difference between the Emissions(in percent) in Canada in 1997 and the Emissions(in percent) in Congo (Democratic) in 1998?
Make the answer very short. -12.55. What is the difference between the Emissions(in percent) in Canada in 1997 and the Emissions(in percent) in Pakistan in 1998?
Make the answer very short. 13.22. What is the difference between the Emissions(in percent) in Congo (Democratic) in 1997 and the Emissions(in percent) in Pakistan in 1998?
Keep it short and to the point. 21.06. What is the difference between the Emissions(in percent) in Bosnia and Herzegovina in 1997 and the Emissions(in percent) in Canada in 1999?
Ensure brevity in your answer.  52.35. What is the difference between the Emissions(in percent) of Bosnia and Herzegovina in 1997 and the Emissions(in percent) of Congo (Democratic) in 1999?
Provide a succinct answer. 35.94. What is the difference between the Emissions(in percent) in Bosnia and Herzegovina in 1997 and the Emissions(in percent) in Pakistan in 1999?
Offer a very short reply. 65.88. What is the difference between the Emissions(in percent) in Canada in 1997 and the Emissions(in percent) in Congo (Democratic) in 1999?
Keep it short and to the point. -16.9. What is the difference between the Emissions(in percent) of Canada in 1997 and the Emissions(in percent) of Pakistan in 1999?
Your answer should be very brief. 13.04. What is the difference between the Emissions(in percent) in Congo (Democratic) in 1997 and the Emissions(in percent) in Pakistan in 1999?
Your response must be concise. 20.88. What is the difference between the Emissions(in percent) in Bosnia and Herzegovina in 1998 and the Emissions(in percent) in Canada in 1999?
Your answer should be very brief. 53.09. What is the difference between the Emissions(in percent) of Bosnia and Herzegovina in 1998 and the Emissions(in percent) of Congo (Democratic) in 1999?
Offer a very short reply. 36.68. What is the difference between the Emissions(in percent) in Bosnia and Herzegovina in 1998 and the Emissions(in percent) in Pakistan in 1999?
Offer a terse response. 66.62. What is the difference between the Emissions(in percent) in Canada in 1998 and the Emissions(in percent) in Congo (Democratic) in 1999?
Your response must be concise. -16. What is the difference between the Emissions(in percent) in Canada in 1998 and the Emissions(in percent) in Pakistan in 1999?
Provide a short and direct response. 13.93. What is the difference between the Emissions(in percent) of Congo (Democratic) in 1998 and the Emissions(in percent) of Pakistan in 1999?
Provide a succinct answer. 25.59. What is the average Emissions(in percent) in Bosnia and Herzegovina per year?
Your response must be concise. 53.91. What is the average Emissions(in percent) of Canada per year?
Ensure brevity in your answer.  21.68. What is the average Emissions(in percent) in Congo (Democratic) per year?
Offer a very short reply. 29.63. What is the average Emissions(in percent) of Pakistan per year?
Make the answer very short. 9.88. In the year 1992, what is the difference between the Emissions(in percent) in Bosnia and Herzegovina and Emissions(in percent) in Canada?
Offer a very short reply. 17.49. In the year 1992, what is the difference between the Emissions(in percent) of Bosnia and Herzegovina and Emissions(in percent) of Congo (Democratic)?
Make the answer very short. 18.52. In the year 1992, what is the difference between the Emissions(in percent) of Bosnia and Herzegovina and Emissions(in percent) of Pakistan?
Offer a terse response. 29.11. In the year 1992, what is the difference between the Emissions(in percent) in Canada and Emissions(in percent) in Congo (Democratic)?
Provide a short and direct response. 1.02. In the year 1992, what is the difference between the Emissions(in percent) in Canada and Emissions(in percent) in Pakistan?
Keep it short and to the point. 11.61. In the year 1992, what is the difference between the Emissions(in percent) in Congo (Democratic) and Emissions(in percent) in Pakistan?
Your answer should be very brief. 10.59. In the year 1993, what is the difference between the Emissions(in percent) of Bosnia and Herzegovina and Emissions(in percent) of Canada?
Give a very brief answer. 21.68. In the year 1993, what is the difference between the Emissions(in percent) of Bosnia and Herzegovina and Emissions(in percent) of Congo (Democratic)?
Your answer should be compact. 18.68. In the year 1993, what is the difference between the Emissions(in percent) in Bosnia and Herzegovina and Emissions(in percent) in Pakistan?
Offer a very short reply. 31.8. In the year 1993, what is the difference between the Emissions(in percent) in Canada and Emissions(in percent) in Congo (Democratic)?
Your answer should be compact. -2.99. In the year 1993, what is the difference between the Emissions(in percent) in Canada and Emissions(in percent) in Pakistan?
Offer a very short reply. 10.13. In the year 1993, what is the difference between the Emissions(in percent) of Congo (Democratic) and Emissions(in percent) of Pakistan?
Your response must be concise. 13.12. In the year 1994, what is the difference between the Emissions(in percent) of Bosnia and Herzegovina and Emissions(in percent) of Canada?
Ensure brevity in your answer.  15.34. In the year 1994, what is the difference between the Emissions(in percent) of Bosnia and Herzegovina and Emissions(in percent) of Congo (Democratic)?
Provide a succinct answer. 2.56. In the year 1994, what is the difference between the Emissions(in percent) in Bosnia and Herzegovina and Emissions(in percent) in Pakistan?
Ensure brevity in your answer.  25.57. In the year 1994, what is the difference between the Emissions(in percent) of Canada and Emissions(in percent) of Congo (Democratic)?
Keep it short and to the point. -12.78. In the year 1994, what is the difference between the Emissions(in percent) in Canada and Emissions(in percent) in Pakistan?
Your response must be concise. 10.24. In the year 1994, what is the difference between the Emissions(in percent) in Congo (Democratic) and Emissions(in percent) in Pakistan?
Your answer should be compact. 23.01. In the year 1995, what is the difference between the Emissions(in percent) in Bosnia and Herzegovina and Emissions(in percent) in Canada?
Offer a terse response. 19.16. In the year 1995, what is the difference between the Emissions(in percent) of Bosnia and Herzegovina and Emissions(in percent) of Congo (Democratic)?
Your response must be concise. 11.54. In the year 1995, what is the difference between the Emissions(in percent) of Bosnia and Herzegovina and Emissions(in percent) of Pakistan?
Make the answer very short. 30.34. In the year 1995, what is the difference between the Emissions(in percent) of Canada and Emissions(in percent) of Congo (Democratic)?
Keep it short and to the point. -7.62. In the year 1995, what is the difference between the Emissions(in percent) of Canada and Emissions(in percent) of Pakistan?
Offer a terse response. 11.19. In the year 1995, what is the difference between the Emissions(in percent) of Congo (Democratic) and Emissions(in percent) of Pakistan?
Offer a terse response. 18.81. In the year 1996, what is the difference between the Emissions(in percent) in Bosnia and Herzegovina and Emissions(in percent) in Canada?
Your response must be concise. 25.98. In the year 1996, what is the difference between the Emissions(in percent) in Bosnia and Herzegovina and Emissions(in percent) in Congo (Democratic)?
Your answer should be very brief. 20.64. In the year 1996, what is the difference between the Emissions(in percent) in Bosnia and Herzegovina and Emissions(in percent) in Pakistan?
Your response must be concise. 37.03. In the year 1996, what is the difference between the Emissions(in percent) of Canada and Emissions(in percent) of Congo (Democratic)?
Your answer should be very brief. -5.34. In the year 1996, what is the difference between the Emissions(in percent) of Canada and Emissions(in percent) of Pakistan?
Your answer should be very brief. 11.04. In the year 1996, what is the difference between the Emissions(in percent) of Congo (Democratic) and Emissions(in percent) of Pakistan?
Offer a very short reply. 16.38. In the year 1997, what is the difference between the Emissions(in percent) in Bosnia and Herzegovina and Emissions(in percent) in Canada?
Provide a succinct answer. 52.84. In the year 1997, what is the difference between the Emissions(in percent) in Bosnia and Herzegovina and Emissions(in percent) in Congo (Democratic)?
Your response must be concise. 44.99. In the year 1997, what is the difference between the Emissions(in percent) of Bosnia and Herzegovina and Emissions(in percent) of Pakistan?
Your response must be concise. 65.38. In the year 1997, what is the difference between the Emissions(in percent) of Canada and Emissions(in percent) of Congo (Democratic)?
Ensure brevity in your answer.  -7.84. In the year 1997, what is the difference between the Emissions(in percent) of Canada and Emissions(in percent) of Pakistan?
Make the answer very short. 12.54. In the year 1997, what is the difference between the Emissions(in percent) of Congo (Democratic) and Emissions(in percent) of Pakistan?
Your answer should be compact. 20.39. In the year 1998, what is the difference between the Emissions(in percent) in Bosnia and Herzegovina and Emissions(in percent) in Canada?
Provide a succinct answer. 52.68. In the year 1998, what is the difference between the Emissions(in percent) in Bosnia and Herzegovina and Emissions(in percent) in Congo (Democratic)?
Provide a succinct answer. 41.03. In the year 1998, what is the difference between the Emissions(in percent) of Bosnia and Herzegovina and Emissions(in percent) of Pakistan?
Your answer should be compact. 66.8. In the year 1998, what is the difference between the Emissions(in percent) in Canada and Emissions(in percent) in Congo (Democratic)?
Offer a very short reply. -11.66. In the year 1998, what is the difference between the Emissions(in percent) in Canada and Emissions(in percent) in Pakistan?
Keep it short and to the point. 14.11. In the year 1998, what is the difference between the Emissions(in percent) of Congo (Democratic) and Emissions(in percent) of Pakistan?
Your answer should be compact. 25.77. In the year 1999, what is the difference between the Emissions(in percent) of Bosnia and Herzegovina and Emissions(in percent) of Canada?
Your answer should be compact. 52.72. In the year 1999, what is the difference between the Emissions(in percent) of Bosnia and Herzegovina and Emissions(in percent) of Congo (Democratic)?
Your response must be concise. 36.31. In the year 1999, what is the difference between the Emissions(in percent) of Bosnia and Herzegovina and Emissions(in percent) of Pakistan?
Your answer should be compact. 66.24. In the year 1999, what is the difference between the Emissions(in percent) in Canada and Emissions(in percent) in Congo (Democratic)?
Your response must be concise. -16.41. In the year 1999, what is the difference between the Emissions(in percent) in Canada and Emissions(in percent) in Pakistan?
Give a very brief answer. 13.52. In the year 1999, what is the difference between the Emissions(in percent) of Congo (Democratic) and Emissions(in percent) of Pakistan?
Your answer should be compact. 29.93. What is the ratio of the Emissions(in percent) in Bosnia and Herzegovina in 1992 to that in 1993?
Provide a short and direct response. 0.95. What is the ratio of the Emissions(in percent) in Canada in 1992 to that in 1993?
Your response must be concise. 1.1. What is the ratio of the Emissions(in percent) of Congo (Democratic) in 1992 to that in 1993?
Your answer should be very brief. 0.92. What is the ratio of the Emissions(in percent) in Pakistan in 1992 to that in 1993?
Give a very brief answer. 1.06. What is the ratio of the Emissions(in percent) in Bosnia and Herzegovina in 1992 to that in 1994?
Your response must be concise. 1.11. What is the ratio of the Emissions(in percent) of Canada in 1992 to that in 1994?
Ensure brevity in your answer.  1.1. What is the ratio of the Emissions(in percent) of Congo (Democratic) in 1992 to that in 1994?
Your answer should be very brief. 0.65. What is the ratio of the Emissions(in percent) in Pakistan in 1992 to that in 1994?
Your answer should be very brief. 1.06. What is the ratio of the Emissions(in percent) in Bosnia and Herzegovina in 1992 to that in 1995?
Give a very brief answer. 1.01. What is the ratio of the Emissions(in percent) of Canada in 1992 to that in 1995?
Your response must be concise. 1.1. What is the ratio of the Emissions(in percent) of Congo (Democratic) in 1992 to that in 1995?
Provide a short and direct response. 0.77. What is the ratio of the Emissions(in percent) in Pakistan in 1992 to that in 1995?
Keep it short and to the point. 1.16. What is the ratio of the Emissions(in percent) of Bosnia and Herzegovina in 1992 to that in 1996?
Give a very brief answer. 0.86. What is the ratio of the Emissions(in percent) of Canada in 1992 to that in 1996?
Your answer should be very brief. 1.1. What is the ratio of the Emissions(in percent) of Congo (Democratic) in 1992 to that in 1996?
Give a very brief answer. 0.84. What is the ratio of the Emissions(in percent) of Pakistan in 1992 to that in 1996?
Make the answer very short. 1.16. What is the ratio of the Emissions(in percent) of Bosnia and Herzegovina in 1992 to that in 1997?
Your answer should be compact. 0.55. What is the ratio of the Emissions(in percent) of Canada in 1992 to that in 1997?
Give a very brief answer. 1.07. What is the ratio of the Emissions(in percent) in Pakistan in 1992 to that in 1997?
Your answer should be compact. 1.27. What is the ratio of the Emissions(in percent) in Bosnia and Herzegovina in 1992 to that in 1998?
Keep it short and to the point. 0.54. What is the ratio of the Emissions(in percent) of Canada in 1992 to that in 1998?
Offer a terse response. 1.03. What is the ratio of the Emissions(in percent) of Congo (Democratic) in 1992 to that in 1998?
Your answer should be compact. 0.65. What is the ratio of the Emissions(in percent) of Pakistan in 1992 to that in 1998?
Offer a very short reply. 1.37. What is the ratio of the Emissions(in percent) in Bosnia and Herzegovina in 1992 to that in 1999?
Provide a succinct answer. 0.54. What is the ratio of the Emissions(in percent) in Canada in 1992 to that in 1999?
Offer a terse response. 1.05. What is the ratio of the Emissions(in percent) of Congo (Democratic) in 1992 to that in 1999?
Give a very brief answer. 0.57. What is the ratio of the Emissions(in percent) of Pakistan in 1992 to that in 1999?
Your answer should be very brief. 1.34. What is the ratio of the Emissions(in percent) in Bosnia and Herzegovina in 1993 to that in 1994?
Keep it short and to the point. 1.17. What is the ratio of the Emissions(in percent) of Canada in 1993 to that in 1994?
Give a very brief answer. 0.99. What is the ratio of the Emissions(in percent) of Congo (Democratic) in 1993 to that in 1994?
Give a very brief answer. 0.71. What is the ratio of the Emissions(in percent) in Pakistan in 1993 to that in 1994?
Your response must be concise. 1. What is the ratio of the Emissions(in percent) in Bosnia and Herzegovina in 1993 to that in 1995?
Make the answer very short. 1.06. What is the ratio of the Emissions(in percent) of Canada in 1993 to that in 1995?
Ensure brevity in your answer.  1. What is the ratio of the Emissions(in percent) of Congo (Democratic) in 1993 to that in 1995?
Offer a terse response. 0.84. What is the ratio of the Emissions(in percent) in Pakistan in 1993 to that in 1995?
Your response must be concise. 1.1. What is the ratio of the Emissions(in percent) of Bosnia and Herzegovina in 1993 to that in 1996?
Offer a very short reply. 0.91. What is the ratio of the Emissions(in percent) in Canada in 1993 to that in 1996?
Give a very brief answer. 1. What is the ratio of the Emissions(in percent) of Congo (Democratic) in 1993 to that in 1996?
Offer a terse response. 0.91. What is the ratio of the Emissions(in percent) of Pakistan in 1993 to that in 1996?
Ensure brevity in your answer.  1.1. What is the ratio of the Emissions(in percent) of Bosnia and Herzegovina in 1993 to that in 1997?
Make the answer very short. 0.57. What is the ratio of the Emissions(in percent) in Canada in 1993 to that in 1997?
Your answer should be very brief. 0.97. What is the ratio of the Emissions(in percent) of Congo (Democratic) in 1993 to that in 1997?
Offer a very short reply. 0.81. What is the ratio of the Emissions(in percent) of Pakistan in 1993 to that in 1997?
Keep it short and to the point. 1.2. What is the ratio of the Emissions(in percent) in Bosnia and Herzegovina in 1993 to that in 1998?
Offer a very short reply. 0.57. What is the ratio of the Emissions(in percent) in Canada in 1993 to that in 1998?
Provide a succinct answer. 0.93. What is the ratio of the Emissions(in percent) of Congo (Democratic) in 1993 to that in 1998?
Ensure brevity in your answer.  0.7. What is the ratio of the Emissions(in percent) in Pakistan in 1993 to that in 1998?
Provide a succinct answer. 1.3. What is the ratio of the Emissions(in percent) of Bosnia and Herzegovina in 1993 to that in 1999?
Provide a short and direct response. 0.57. What is the ratio of the Emissions(in percent) in Canada in 1993 to that in 1999?
Your answer should be very brief. 0.95. What is the ratio of the Emissions(in percent) of Congo (Democratic) in 1993 to that in 1999?
Keep it short and to the point. 0.62. What is the ratio of the Emissions(in percent) in Pakistan in 1993 to that in 1999?
Your response must be concise. 1.27. What is the ratio of the Emissions(in percent) of Bosnia and Herzegovina in 1994 to that in 1995?
Your answer should be compact. 0.91. What is the ratio of the Emissions(in percent) in Canada in 1994 to that in 1995?
Your answer should be compact. 1. What is the ratio of the Emissions(in percent) in Congo (Democratic) in 1994 to that in 1995?
Offer a terse response. 1.18. What is the ratio of the Emissions(in percent) in Pakistan in 1994 to that in 1995?
Your answer should be compact. 1.1. What is the ratio of the Emissions(in percent) of Bosnia and Herzegovina in 1994 to that in 1996?
Provide a succinct answer. 0.78. What is the ratio of the Emissions(in percent) of Congo (Democratic) in 1994 to that in 1996?
Give a very brief answer. 1.29. What is the ratio of the Emissions(in percent) of Pakistan in 1994 to that in 1996?
Provide a short and direct response. 1.1. What is the ratio of the Emissions(in percent) in Bosnia and Herzegovina in 1994 to that in 1997?
Make the answer very short. 0.49. What is the ratio of the Emissions(in percent) in Canada in 1994 to that in 1997?
Offer a very short reply. 0.98. What is the ratio of the Emissions(in percent) of Congo (Democratic) in 1994 to that in 1997?
Your answer should be compact. 1.15. What is the ratio of the Emissions(in percent) in Pakistan in 1994 to that in 1997?
Offer a very short reply. 1.2. What is the ratio of the Emissions(in percent) of Bosnia and Herzegovina in 1994 to that in 1998?
Offer a very short reply. 0.48. What is the ratio of the Emissions(in percent) of Canada in 1994 to that in 1998?
Give a very brief answer. 0.94. What is the ratio of the Emissions(in percent) of Pakistan in 1994 to that in 1998?
Keep it short and to the point. 1.3. What is the ratio of the Emissions(in percent) in Bosnia and Herzegovina in 1994 to that in 1999?
Give a very brief answer. 0.49. What is the ratio of the Emissions(in percent) of Canada in 1994 to that in 1999?
Keep it short and to the point. 0.96. What is the ratio of the Emissions(in percent) in Congo (Democratic) in 1994 to that in 1999?
Your response must be concise. 0.88. What is the ratio of the Emissions(in percent) of Pakistan in 1994 to that in 1999?
Offer a very short reply. 1.27. What is the ratio of the Emissions(in percent) of Bosnia and Herzegovina in 1995 to that in 1996?
Give a very brief answer. 0.86. What is the ratio of the Emissions(in percent) of Congo (Democratic) in 1995 to that in 1996?
Ensure brevity in your answer.  1.09. What is the ratio of the Emissions(in percent) of Pakistan in 1995 to that in 1996?
Offer a very short reply. 1. What is the ratio of the Emissions(in percent) in Bosnia and Herzegovina in 1995 to that in 1997?
Ensure brevity in your answer.  0.54. What is the ratio of the Emissions(in percent) of Canada in 1995 to that in 1997?
Your response must be concise. 0.97. What is the ratio of the Emissions(in percent) of Congo (Democratic) in 1995 to that in 1997?
Keep it short and to the point. 0.97. What is the ratio of the Emissions(in percent) in Pakistan in 1995 to that in 1997?
Provide a short and direct response. 1.09. What is the ratio of the Emissions(in percent) of Bosnia and Herzegovina in 1995 to that in 1998?
Offer a terse response. 0.53. What is the ratio of the Emissions(in percent) in Canada in 1995 to that in 1998?
Offer a very short reply. 0.94. What is the ratio of the Emissions(in percent) in Congo (Democratic) in 1995 to that in 1998?
Offer a terse response. 0.84. What is the ratio of the Emissions(in percent) in Pakistan in 1995 to that in 1998?
Make the answer very short. 1.18. What is the ratio of the Emissions(in percent) of Bosnia and Herzegovina in 1995 to that in 1999?
Provide a short and direct response. 0.54. What is the ratio of the Emissions(in percent) of Canada in 1995 to that in 1999?
Provide a short and direct response. 0.95. What is the ratio of the Emissions(in percent) in Congo (Democratic) in 1995 to that in 1999?
Provide a succinct answer. 0.74. What is the ratio of the Emissions(in percent) in Pakistan in 1995 to that in 1999?
Keep it short and to the point. 1.15. What is the ratio of the Emissions(in percent) in Bosnia and Herzegovina in 1996 to that in 1997?
Provide a short and direct response. 0.63. What is the ratio of the Emissions(in percent) of Canada in 1996 to that in 1997?
Offer a very short reply. 0.97. What is the ratio of the Emissions(in percent) in Congo (Democratic) in 1996 to that in 1997?
Your answer should be very brief. 0.89. What is the ratio of the Emissions(in percent) in Pakistan in 1996 to that in 1997?
Provide a short and direct response. 1.09. What is the ratio of the Emissions(in percent) in Bosnia and Herzegovina in 1996 to that in 1998?
Provide a succinct answer. 0.62. What is the ratio of the Emissions(in percent) in Canada in 1996 to that in 1998?
Make the answer very short. 0.93. What is the ratio of the Emissions(in percent) of Congo (Democratic) in 1996 to that in 1998?
Ensure brevity in your answer.  0.77. What is the ratio of the Emissions(in percent) of Pakistan in 1996 to that in 1998?
Make the answer very short. 1.18. What is the ratio of the Emissions(in percent) in Bosnia and Herzegovina in 1996 to that in 1999?
Provide a succinct answer. 0.63. What is the ratio of the Emissions(in percent) of Canada in 1996 to that in 1999?
Ensure brevity in your answer.  0.95. What is the ratio of the Emissions(in percent) in Congo (Democratic) in 1996 to that in 1999?
Offer a terse response. 0.68. What is the ratio of the Emissions(in percent) in Pakistan in 1996 to that in 1999?
Make the answer very short. 1.16. What is the ratio of the Emissions(in percent) in Bosnia and Herzegovina in 1997 to that in 1998?
Your answer should be very brief. 0.99. What is the ratio of the Emissions(in percent) of Canada in 1997 to that in 1998?
Provide a short and direct response. 0.96. What is the ratio of the Emissions(in percent) in Congo (Democratic) in 1997 to that in 1998?
Your answer should be very brief. 0.86. What is the ratio of the Emissions(in percent) of Pakistan in 1997 to that in 1998?
Ensure brevity in your answer.  1.08. What is the ratio of the Emissions(in percent) of Congo (Democratic) in 1997 to that in 1999?
Your answer should be very brief. 0.76. What is the ratio of the Emissions(in percent) of Pakistan in 1997 to that in 1999?
Offer a terse response. 1.06. What is the ratio of the Emissions(in percent) in Bosnia and Herzegovina in 1998 to that in 1999?
Your answer should be compact. 1. What is the ratio of the Emissions(in percent) in Canada in 1998 to that in 1999?
Keep it short and to the point. 1.02. What is the ratio of the Emissions(in percent) in Congo (Democratic) in 1998 to that in 1999?
Provide a succinct answer. 0.89. What is the ratio of the Emissions(in percent) of Pakistan in 1998 to that in 1999?
Give a very brief answer. 0.98. What is the difference between the highest and the second highest Emissions(in percent) in Bosnia and Herzegovina?
Make the answer very short. 0.38. What is the difference between the highest and the second highest Emissions(in percent) in Canada?
Keep it short and to the point. 0.61. What is the difference between the highest and the second highest Emissions(in percent) in Congo (Democratic)?
Keep it short and to the point. 4.35. What is the difference between the highest and the second highest Emissions(in percent) in Pakistan?
Make the answer very short. 0.63. What is the difference between the highest and the lowest Emissions(in percent) in Bosnia and Herzegovina?
Give a very brief answer. 38.75. What is the difference between the highest and the lowest Emissions(in percent) in Canada?
Your answer should be compact. 2.15. What is the difference between the highest and the lowest Emissions(in percent) in Congo (Democratic)?
Offer a terse response. 16.41. What is the difference between the highest and the lowest Emissions(in percent) in Pakistan?
Keep it short and to the point. 3.11. 